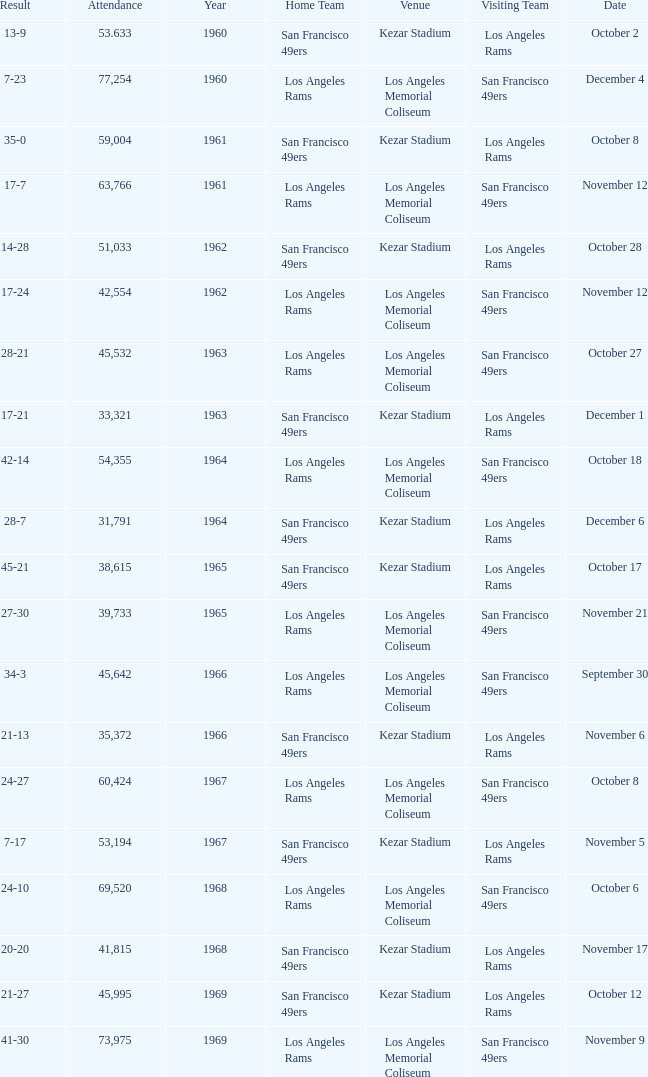What was the total attendance for a result of 7-23 before 1960? None. 